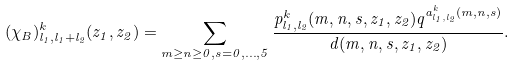<formula> <loc_0><loc_0><loc_500><loc_500>( \chi _ { B } ) ^ { k } _ { l _ { 1 } , l _ { 1 } + l _ { 2 } } ( z _ { 1 } , z _ { 2 } ) = \sum _ { m \geq n \geq 0 , s = 0 , \dots , 5 } \frac { p ^ { k } _ { l _ { 1 } , l _ { 2 } } ( m , n , s , z _ { 1 } , z _ { 2 } ) q ^ { a ^ { k } _ { l _ { 1 } , l _ { 2 } } ( m , n , s ) } } { d ( m , n , s , z _ { 1 } , z _ { 2 } ) } .</formula> 